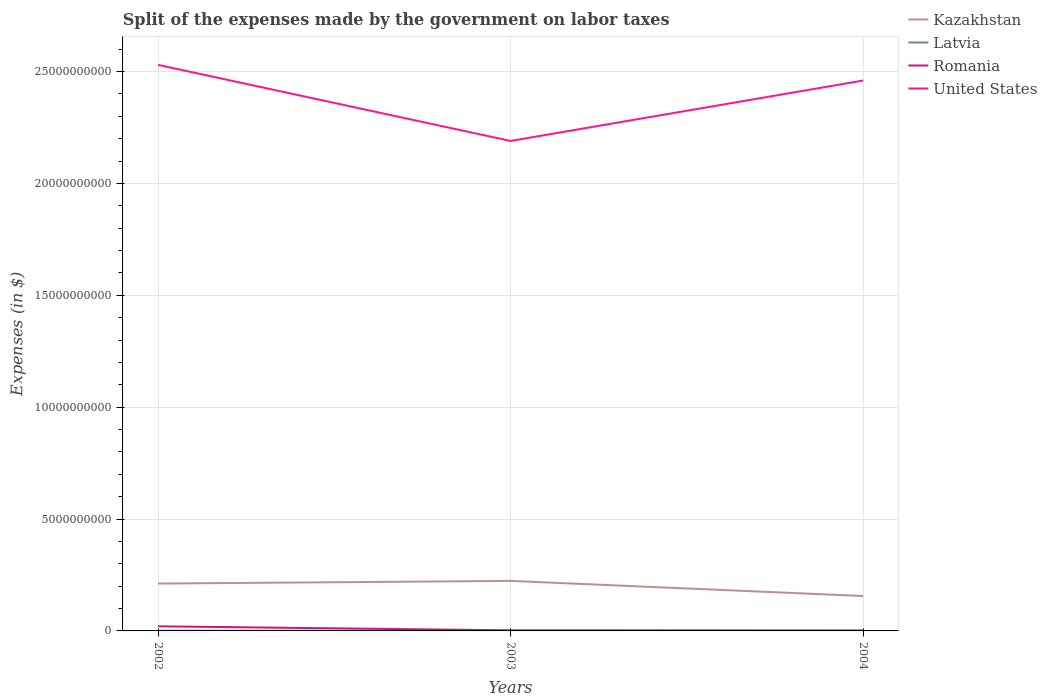How many different coloured lines are there?
Give a very brief answer. 4. Does the line corresponding to Latvia intersect with the line corresponding to United States?
Give a very brief answer. No. Across all years, what is the maximum expenses made by the government on labor taxes in Latvia?
Make the answer very short. 6.10e+06. What is the total expenses made by the government on labor taxes in Latvia in the graph?
Your response must be concise. 8.00e+05. What is the difference between the highest and the second highest expenses made by the government on labor taxes in Kazakhstan?
Provide a short and direct response. 6.75e+08. What is the difference between the highest and the lowest expenses made by the government on labor taxes in Romania?
Your response must be concise. 1. Is the expenses made by the government on labor taxes in United States strictly greater than the expenses made by the government on labor taxes in Romania over the years?
Offer a very short reply. No. How many lines are there?
Offer a very short reply. 4. How many years are there in the graph?
Provide a short and direct response. 3. What is the difference between two consecutive major ticks on the Y-axis?
Ensure brevity in your answer.  5.00e+09. Are the values on the major ticks of Y-axis written in scientific E-notation?
Keep it short and to the point. No. Does the graph contain any zero values?
Make the answer very short. No. Where does the legend appear in the graph?
Offer a terse response. Top right. How many legend labels are there?
Your answer should be very brief. 4. What is the title of the graph?
Make the answer very short. Split of the expenses made by the government on labor taxes. Does "Central African Republic" appear as one of the legend labels in the graph?
Your response must be concise. No. What is the label or title of the Y-axis?
Give a very brief answer. Expenses (in $). What is the Expenses (in $) of Kazakhstan in 2002?
Ensure brevity in your answer.  2.12e+09. What is the Expenses (in $) of Latvia in 2002?
Your answer should be compact. 8.60e+06. What is the Expenses (in $) of Romania in 2002?
Offer a terse response. 2.06e+08. What is the Expenses (in $) of United States in 2002?
Give a very brief answer. 2.53e+1. What is the Expenses (in $) of Kazakhstan in 2003?
Offer a very short reply. 2.24e+09. What is the Expenses (in $) in Latvia in 2003?
Your answer should be very brief. 7.80e+06. What is the Expenses (in $) of Romania in 2003?
Keep it short and to the point. 2.57e+07. What is the Expenses (in $) of United States in 2003?
Your response must be concise. 2.19e+1. What is the Expenses (in $) of Kazakhstan in 2004?
Your answer should be very brief. 1.56e+09. What is the Expenses (in $) of Latvia in 2004?
Offer a very short reply. 6.10e+06. What is the Expenses (in $) in Romania in 2004?
Give a very brief answer. 1.92e+07. What is the Expenses (in $) in United States in 2004?
Provide a short and direct response. 2.46e+1. Across all years, what is the maximum Expenses (in $) in Kazakhstan?
Make the answer very short. 2.24e+09. Across all years, what is the maximum Expenses (in $) in Latvia?
Ensure brevity in your answer.  8.60e+06. Across all years, what is the maximum Expenses (in $) in Romania?
Keep it short and to the point. 2.06e+08. Across all years, what is the maximum Expenses (in $) in United States?
Offer a terse response. 2.53e+1. Across all years, what is the minimum Expenses (in $) in Kazakhstan?
Your answer should be compact. 1.56e+09. Across all years, what is the minimum Expenses (in $) of Latvia?
Give a very brief answer. 6.10e+06. Across all years, what is the minimum Expenses (in $) in Romania?
Offer a very short reply. 1.92e+07. Across all years, what is the minimum Expenses (in $) in United States?
Give a very brief answer. 2.19e+1. What is the total Expenses (in $) in Kazakhstan in the graph?
Your response must be concise. 5.91e+09. What is the total Expenses (in $) in Latvia in the graph?
Ensure brevity in your answer.  2.25e+07. What is the total Expenses (in $) in Romania in the graph?
Keep it short and to the point. 2.51e+08. What is the total Expenses (in $) of United States in the graph?
Give a very brief answer. 7.18e+1. What is the difference between the Expenses (in $) in Kazakhstan in 2002 and that in 2003?
Ensure brevity in your answer.  -1.19e+08. What is the difference between the Expenses (in $) in Latvia in 2002 and that in 2003?
Offer a very short reply. 8.00e+05. What is the difference between the Expenses (in $) of Romania in 2002 and that in 2003?
Ensure brevity in your answer.  1.80e+08. What is the difference between the Expenses (in $) of United States in 2002 and that in 2003?
Give a very brief answer. 3.40e+09. What is the difference between the Expenses (in $) in Kazakhstan in 2002 and that in 2004?
Offer a very short reply. 5.57e+08. What is the difference between the Expenses (in $) of Latvia in 2002 and that in 2004?
Make the answer very short. 2.50e+06. What is the difference between the Expenses (in $) of Romania in 2002 and that in 2004?
Provide a succinct answer. 1.87e+08. What is the difference between the Expenses (in $) in United States in 2002 and that in 2004?
Give a very brief answer. 7.00e+08. What is the difference between the Expenses (in $) of Kazakhstan in 2003 and that in 2004?
Your answer should be compact. 6.75e+08. What is the difference between the Expenses (in $) in Latvia in 2003 and that in 2004?
Ensure brevity in your answer.  1.70e+06. What is the difference between the Expenses (in $) of Romania in 2003 and that in 2004?
Your response must be concise. 6.55e+06. What is the difference between the Expenses (in $) of United States in 2003 and that in 2004?
Provide a succinct answer. -2.70e+09. What is the difference between the Expenses (in $) of Kazakhstan in 2002 and the Expenses (in $) of Latvia in 2003?
Offer a terse response. 2.11e+09. What is the difference between the Expenses (in $) in Kazakhstan in 2002 and the Expenses (in $) in Romania in 2003?
Give a very brief answer. 2.09e+09. What is the difference between the Expenses (in $) in Kazakhstan in 2002 and the Expenses (in $) in United States in 2003?
Make the answer very short. -1.98e+1. What is the difference between the Expenses (in $) in Latvia in 2002 and the Expenses (in $) in Romania in 2003?
Offer a terse response. -1.71e+07. What is the difference between the Expenses (in $) of Latvia in 2002 and the Expenses (in $) of United States in 2003?
Make the answer very short. -2.19e+1. What is the difference between the Expenses (in $) of Romania in 2002 and the Expenses (in $) of United States in 2003?
Keep it short and to the point. -2.17e+1. What is the difference between the Expenses (in $) in Kazakhstan in 2002 and the Expenses (in $) in Latvia in 2004?
Your answer should be compact. 2.11e+09. What is the difference between the Expenses (in $) in Kazakhstan in 2002 and the Expenses (in $) in Romania in 2004?
Provide a succinct answer. 2.10e+09. What is the difference between the Expenses (in $) of Kazakhstan in 2002 and the Expenses (in $) of United States in 2004?
Make the answer very short. -2.25e+1. What is the difference between the Expenses (in $) of Latvia in 2002 and the Expenses (in $) of Romania in 2004?
Make the answer very short. -1.06e+07. What is the difference between the Expenses (in $) in Latvia in 2002 and the Expenses (in $) in United States in 2004?
Give a very brief answer. -2.46e+1. What is the difference between the Expenses (in $) of Romania in 2002 and the Expenses (in $) of United States in 2004?
Give a very brief answer. -2.44e+1. What is the difference between the Expenses (in $) in Kazakhstan in 2003 and the Expenses (in $) in Latvia in 2004?
Provide a short and direct response. 2.23e+09. What is the difference between the Expenses (in $) in Kazakhstan in 2003 and the Expenses (in $) in Romania in 2004?
Your answer should be compact. 2.22e+09. What is the difference between the Expenses (in $) of Kazakhstan in 2003 and the Expenses (in $) of United States in 2004?
Keep it short and to the point. -2.24e+1. What is the difference between the Expenses (in $) in Latvia in 2003 and the Expenses (in $) in Romania in 2004?
Make the answer very short. -1.14e+07. What is the difference between the Expenses (in $) in Latvia in 2003 and the Expenses (in $) in United States in 2004?
Your answer should be compact. -2.46e+1. What is the difference between the Expenses (in $) of Romania in 2003 and the Expenses (in $) of United States in 2004?
Provide a succinct answer. -2.46e+1. What is the average Expenses (in $) in Kazakhstan per year?
Give a very brief answer. 1.97e+09. What is the average Expenses (in $) of Latvia per year?
Keep it short and to the point. 7.50e+06. What is the average Expenses (in $) in Romania per year?
Provide a short and direct response. 8.36e+07. What is the average Expenses (in $) in United States per year?
Keep it short and to the point. 2.39e+1. In the year 2002, what is the difference between the Expenses (in $) in Kazakhstan and Expenses (in $) in Latvia?
Ensure brevity in your answer.  2.11e+09. In the year 2002, what is the difference between the Expenses (in $) of Kazakhstan and Expenses (in $) of Romania?
Keep it short and to the point. 1.91e+09. In the year 2002, what is the difference between the Expenses (in $) in Kazakhstan and Expenses (in $) in United States?
Keep it short and to the point. -2.32e+1. In the year 2002, what is the difference between the Expenses (in $) in Latvia and Expenses (in $) in Romania?
Keep it short and to the point. -1.97e+08. In the year 2002, what is the difference between the Expenses (in $) of Latvia and Expenses (in $) of United States?
Offer a terse response. -2.53e+1. In the year 2002, what is the difference between the Expenses (in $) in Romania and Expenses (in $) in United States?
Provide a succinct answer. -2.51e+1. In the year 2003, what is the difference between the Expenses (in $) in Kazakhstan and Expenses (in $) in Latvia?
Your answer should be compact. 2.23e+09. In the year 2003, what is the difference between the Expenses (in $) of Kazakhstan and Expenses (in $) of Romania?
Make the answer very short. 2.21e+09. In the year 2003, what is the difference between the Expenses (in $) in Kazakhstan and Expenses (in $) in United States?
Keep it short and to the point. -1.97e+1. In the year 2003, what is the difference between the Expenses (in $) of Latvia and Expenses (in $) of Romania?
Give a very brief answer. -1.79e+07. In the year 2003, what is the difference between the Expenses (in $) in Latvia and Expenses (in $) in United States?
Your response must be concise. -2.19e+1. In the year 2003, what is the difference between the Expenses (in $) in Romania and Expenses (in $) in United States?
Keep it short and to the point. -2.19e+1. In the year 2004, what is the difference between the Expenses (in $) in Kazakhstan and Expenses (in $) in Latvia?
Give a very brief answer. 1.55e+09. In the year 2004, what is the difference between the Expenses (in $) in Kazakhstan and Expenses (in $) in Romania?
Offer a very short reply. 1.54e+09. In the year 2004, what is the difference between the Expenses (in $) in Kazakhstan and Expenses (in $) in United States?
Offer a very short reply. -2.30e+1. In the year 2004, what is the difference between the Expenses (in $) in Latvia and Expenses (in $) in Romania?
Your response must be concise. -1.31e+07. In the year 2004, what is the difference between the Expenses (in $) in Latvia and Expenses (in $) in United States?
Provide a short and direct response. -2.46e+1. In the year 2004, what is the difference between the Expenses (in $) of Romania and Expenses (in $) of United States?
Make the answer very short. -2.46e+1. What is the ratio of the Expenses (in $) in Kazakhstan in 2002 to that in 2003?
Provide a succinct answer. 0.95. What is the ratio of the Expenses (in $) of Latvia in 2002 to that in 2003?
Provide a succinct answer. 1.1. What is the ratio of the Expenses (in $) of Romania in 2002 to that in 2003?
Give a very brief answer. 8. What is the ratio of the Expenses (in $) of United States in 2002 to that in 2003?
Provide a succinct answer. 1.16. What is the ratio of the Expenses (in $) of Kazakhstan in 2002 to that in 2004?
Provide a short and direct response. 1.36. What is the ratio of the Expenses (in $) of Latvia in 2002 to that in 2004?
Offer a terse response. 1.41. What is the ratio of the Expenses (in $) of Romania in 2002 to that in 2004?
Your answer should be very brief. 10.73. What is the ratio of the Expenses (in $) of United States in 2002 to that in 2004?
Provide a short and direct response. 1.03. What is the ratio of the Expenses (in $) of Kazakhstan in 2003 to that in 2004?
Make the answer very short. 1.43. What is the ratio of the Expenses (in $) in Latvia in 2003 to that in 2004?
Your response must be concise. 1.28. What is the ratio of the Expenses (in $) of Romania in 2003 to that in 2004?
Make the answer very short. 1.34. What is the ratio of the Expenses (in $) of United States in 2003 to that in 2004?
Offer a very short reply. 0.89. What is the difference between the highest and the second highest Expenses (in $) in Kazakhstan?
Your answer should be compact. 1.19e+08. What is the difference between the highest and the second highest Expenses (in $) of Romania?
Ensure brevity in your answer.  1.80e+08. What is the difference between the highest and the second highest Expenses (in $) of United States?
Your answer should be very brief. 7.00e+08. What is the difference between the highest and the lowest Expenses (in $) of Kazakhstan?
Provide a short and direct response. 6.75e+08. What is the difference between the highest and the lowest Expenses (in $) in Latvia?
Offer a very short reply. 2.50e+06. What is the difference between the highest and the lowest Expenses (in $) of Romania?
Offer a very short reply. 1.87e+08. What is the difference between the highest and the lowest Expenses (in $) in United States?
Ensure brevity in your answer.  3.40e+09. 